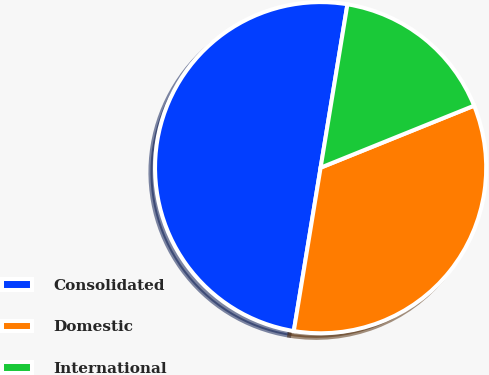<chart> <loc_0><loc_0><loc_500><loc_500><pie_chart><fcel>Consolidated<fcel>Domestic<fcel>International<nl><fcel>50.0%<fcel>33.7%<fcel>16.3%<nl></chart> 